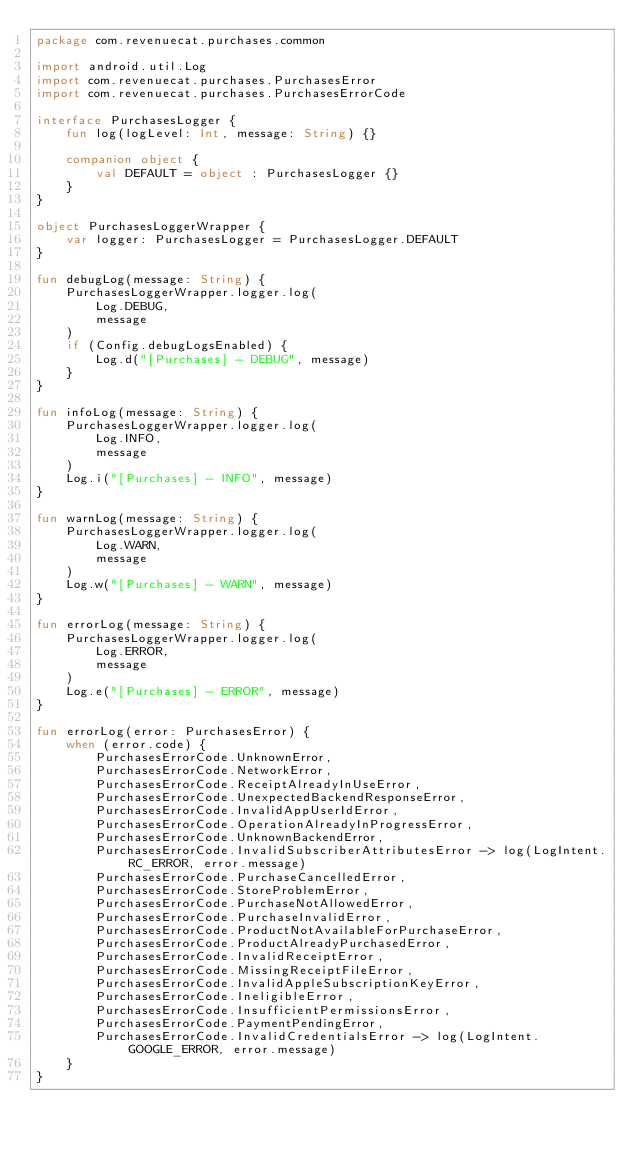<code> <loc_0><loc_0><loc_500><loc_500><_Kotlin_>package com.revenuecat.purchases.common

import android.util.Log
import com.revenuecat.purchases.PurchasesError
import com.revenuecat.purchases.PurchasesErrorCode

interface PurchasesLogger {
    fun log(logLevel: Int, message: String) {}

    companion object {
        val DEFAULT = object : PurchasesLogger {}
    }
}

object PurchasesLoggerWrapper {
    var logger: PurchasesLogger = PurchasesLogger.DEFAULT
}

fun debugLog(message: String) {
    PurchasesLoggerWrapper.logger.log(
        Log.DEBUG,
        message
    )
    if (Config.debugLogsEnabled) {
        Log.d("[Purchases] - DEBUG", message)
    }
}

fun infoLog(message: String) {
    PurchasesLoggerWrapper.logger.log(
        Log.INFO,
        message
    )
    Log.i("[Purchases] - INFO", message)
}

fun warnLog(message: String) {
    PurchasesLoggerWrapper.logger.log(
        Log.WARN,
        message
    )
    Log.w("[Purchases] - WARN", message)
}

fun errorLog(message: String) {
    PurchasesLoggerWrapper.logger.log(
        Log.ERROR,
        message
    )
    Log.e("[Purchases] - ERROR", message)
}

fun errorLog(error: PurchasesError) {
    when (error.code) {
        PurchasesErrorCode.UnknownError,
        PurchasesErrorCode.NetworkError,
        PurchasesErrorCode.ReceiptAlreadyInUseError,
        PurchasesErrorCode.UnexpectedBackendResponseError,
        PurchasesErrorCode.InvalidAppUserIdError,
        PurchasesErrorCode.OperationAlreadyInProgressError,
        PurchasesErrorCode.UnknownBackendError,
        PurchasesErrorCode.InvalidSubscriberAttributesError -> log(LogIntent.RC_ERROR, error.message)
        PurchasesErrorCode.PurchaseCancelledError,
        PurchasesErrorCode.StoreProblemError,
        PurchasesErrorCode.PurchaseNotAllowedError,
        PurchasesErrorCode.PurchaseInvalidError,
        PurchasesErrorCode.ProductNotAvailableForPurchaseError,
        PurchasesErrorCode.ProductAlreadyPurchasedError,
        PurchasesErrorCode.InvalidReceiptError,
        PurchasesErrorCode.MissingReceiptFileError,
        PurchasesErrorCode.InvalidAppleSubscriptionKeyError,
        PurchasesErrorCode.IneligibleError,
        PurchasesErrorCode.InsufficientPermissionsError,
        PurchasesErrorCode.PaymentPendingError,
        PurchasesErrorCode.InvalidCredentialsError -> log(LogIntent.GOOGLE_ERROR, error.message)
    }
}
</code> 